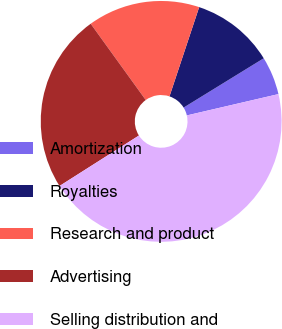Convert chart. <chart><loc_0><loc_0><loc_500><loc_500><pie_chart><fcel>Amortization<fcel>Royalties<fcel>Research and product<fcel>Advertising<fcel>Selling distribution and<nl><fcel>5.14%<fcel>11.11%<fcel>15.06%<fcel>24.06%<fcel>44.63%<nl></chart> 